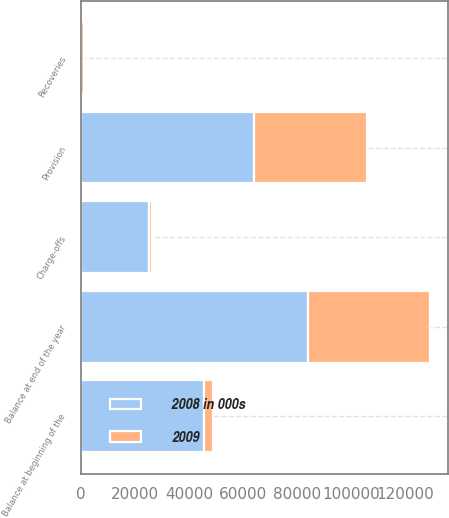<chart> <loc_0><loc_0><loc_500><loc_500><stacked_bar_chart><ecel><fcel>Balance at beginning of the<fcel>Provision<fcel>Recoveries<fcel>Charge-offs<fcel>Balance at end of the year<nl><fcel>2008 in 000s<fcel>45401<fcel>63897<fcel>54<fcel>25279<fcel>84073<nl><fcel>2009<fcel>3448<fcel>42004<fcel>999<fcel>1050<fcel>45401<nl></chart> 